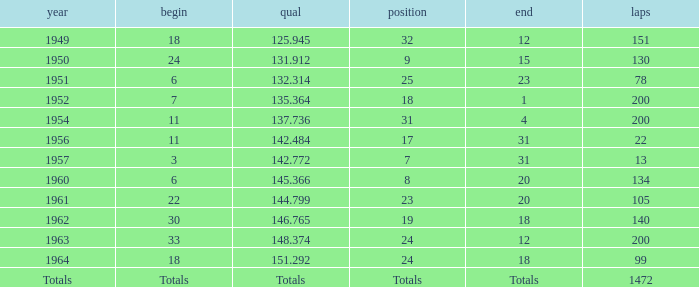Name the rank for laps less than 130 and year of 1951 25.0. Could you help me parse every detail presented in this table? {'header': ['year', 'begin', 'qual', 'position', 'end', 'laps'], 'rows': [['1949', '18', '125.945', '32', '12', '151'], ['1950', '24', '131.912', '9', '15', '130'], ['1951', '6', '132.314', '25', '23', '78'], ['1952', '7', '135.364', '18', '1', '200'], ['1954', '11', '137.736', '31', '4', '200'], ['1956', '11', '142.484', '17', '31', '22'], ['1957', '3', '142.772', '7', '31', '13'], ['1960', '6', '145.366', '8', '20', '134'], ['1961', '22', '144.799', '23', '20', '105'], ['1962', '30', '146.765', '19', '18', '140'], ['1963', '33', '148.374', '24', '12', '200'], ['1964', '18', '151.292', '24', '18', '99'], ['Totals', 'Totals', 'Totals', 'Totals', 'Totals', '1472']]} 